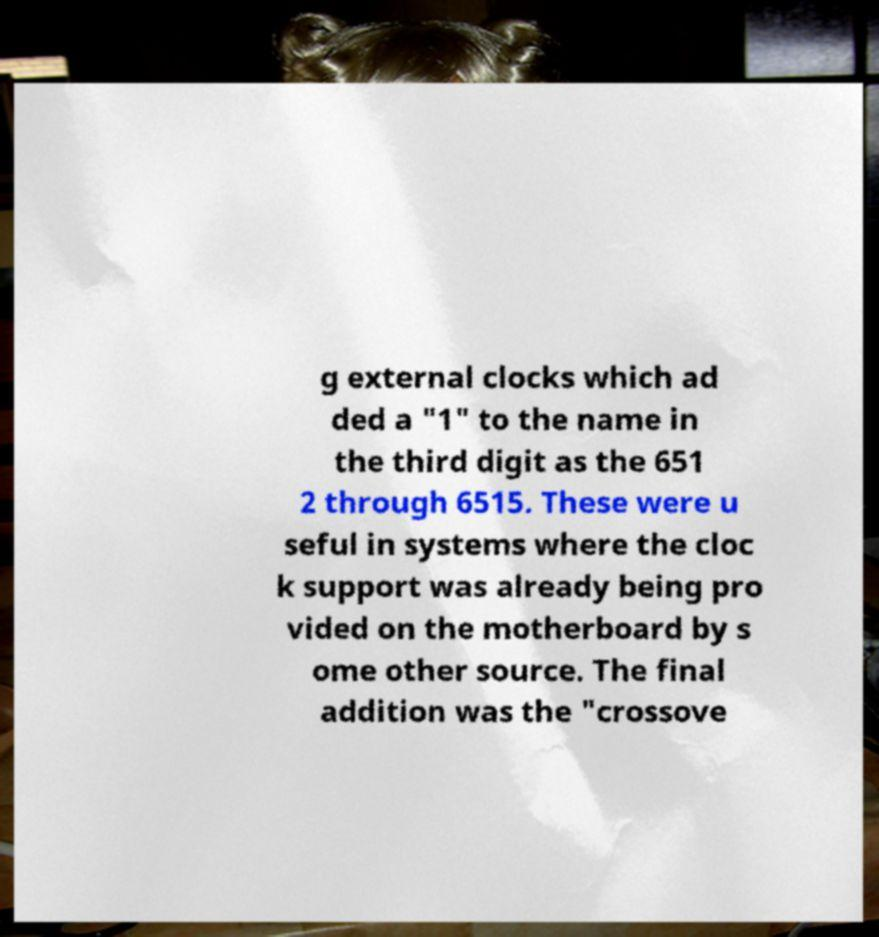Please identify and transcribe the text found in this image. g external clocks which ad ded a "1" to the name in the third digit as the 651 2 through 6515. These were u seful in systems where the cloc k support was already being pro vided on the motherboard by s ome other source. The final addition was the "crossove 